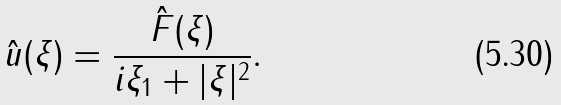<formula> <loc_0><loc_0><loc_500><loc_500>\hat { u } ( \xi ) = \frac { \hat { F } ( \xi ) } { i \xi _ { 1 } + | \xi | ^ { 2 } } .</formula> 